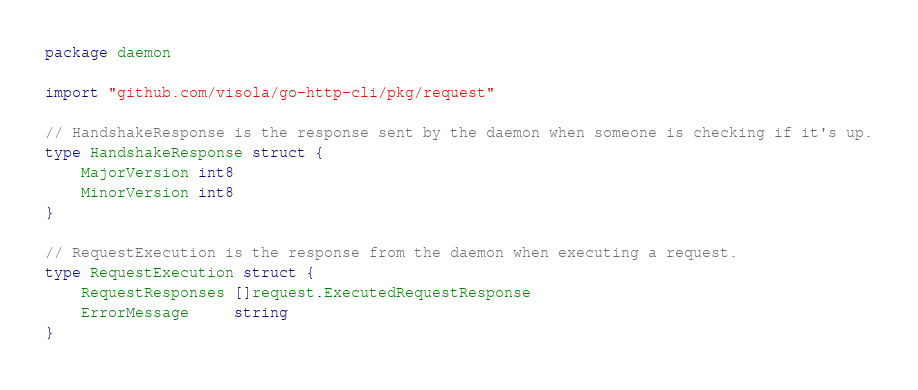<code> <loc_0><loc_0><loc_500><loc_500><_Go_>package daemon

import "github.com/visola/go-http-cli/pkg/request"

// HandshakeResponse is the response sent by the daemon when someone is checking if it's up.
type HandshakeResponse struct {
	MajorVersion int8
	MinorVersion int8
}

// RequestExecution is the response from the daemon when executing a request.
type RequestExecution struct {
	RequestResponses []request.ExecutedRequestResponse
	ErrorMessage     string
}
</code> 